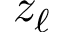Convert formula to latex. <formula><loc_0><loc_0><loc_500><loc_500>z _ { \ell }</formula> 